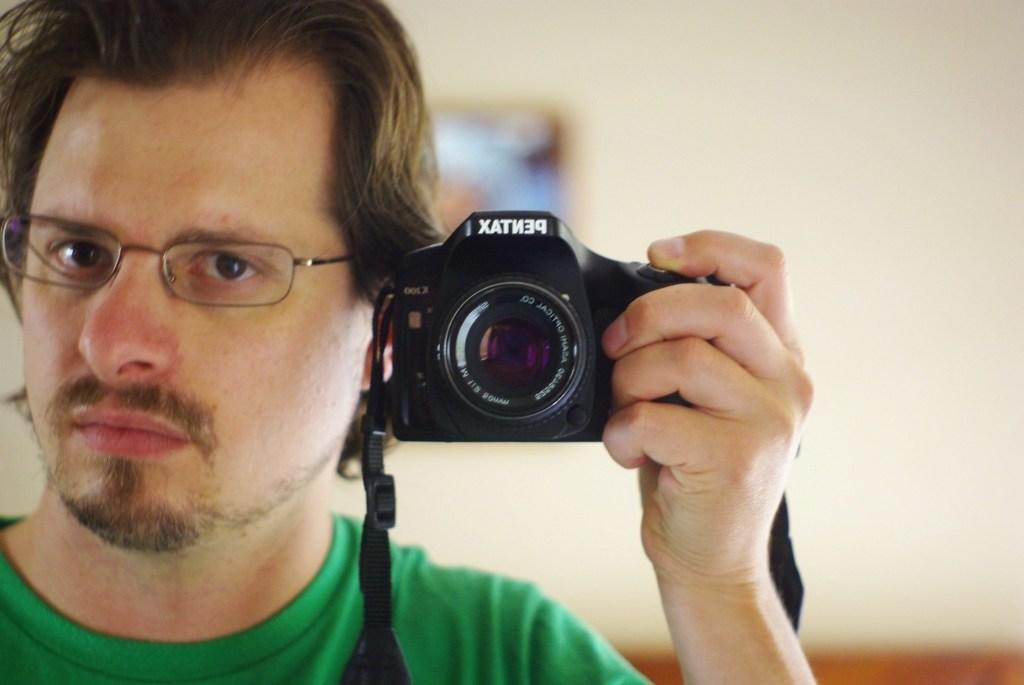What is the main subject of the image? The main subject of the image is a man. What is the man holding in his hand? The man is holding a camera in his hand. Can you describe any accessories the man is wearing? The man is wearing spectacles. What can be seen in the background of the image? There is a wall in the background of the image. Are there any objects on the wall? Yes, there is a picture frame on the wall. Can you tell me how many cows are grazing on the grass in the image? There are no cows or grass present in the image; it features a man holding a camera and wearing spectacles with a wall and picture frame in the background. 